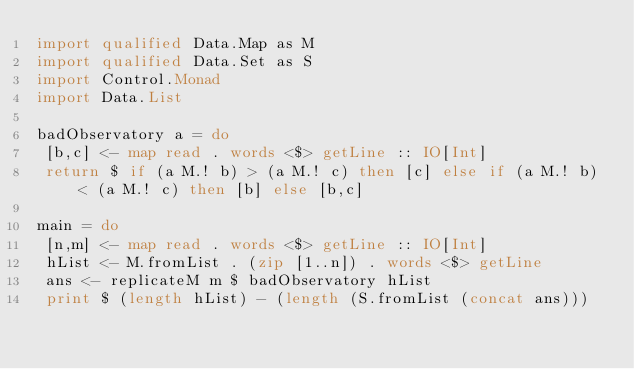Convert code to text. <code><loc_0><loc_0><loc_500><loc_500><_Haskell_>import qualified Data.Map as M
import qualified Data.Set as S
import Control.Monad
import Data.List

badObservatory a = do
 [b,c] <- map read . words <$> getLine :: IO[Int]
 return $ if (a M.! b) > (a M.! c) then [c] else if (a M.! b) < (a M.! c) then [b] else [b,c] 

main = do
 [n,m] <- map read . words <$> getLine :: IO[Int]
 hList <- M.fromList . (zip [1..n]) . words <$> getLine
 ans <- replicateM m $ badObservatory hList
 print $ (length hList) - (length (S.fromList (concat ans)))
</code> 